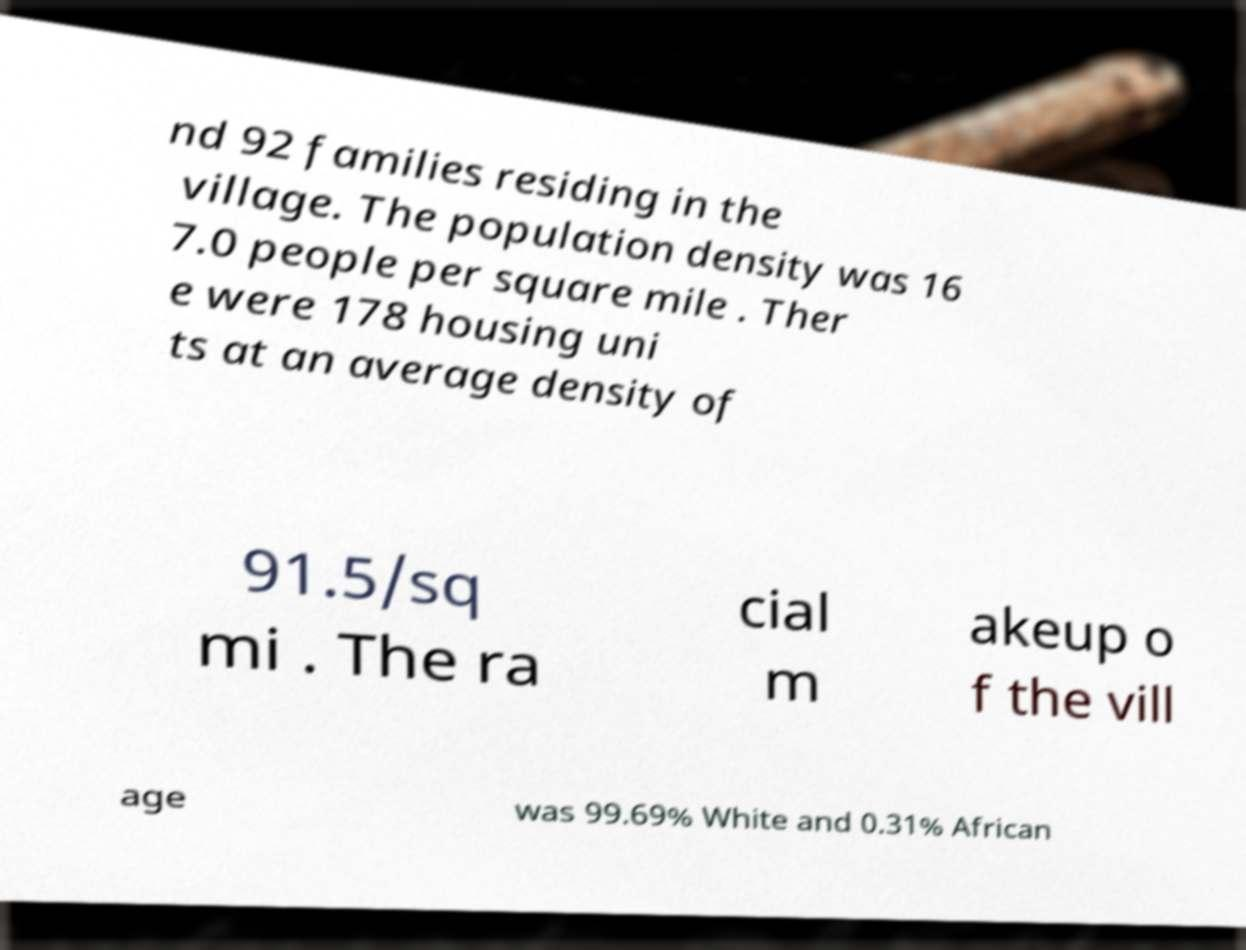Could you extract and type out the text from this image? nd 92 families residing in the village. The population density was 16 7.0 people per square mile . Ther e were 178 housing uni ts at an average density of 91.5/sq mi . The ra cial m akeup o f the vill age was 99.69% White and 0.31% African 